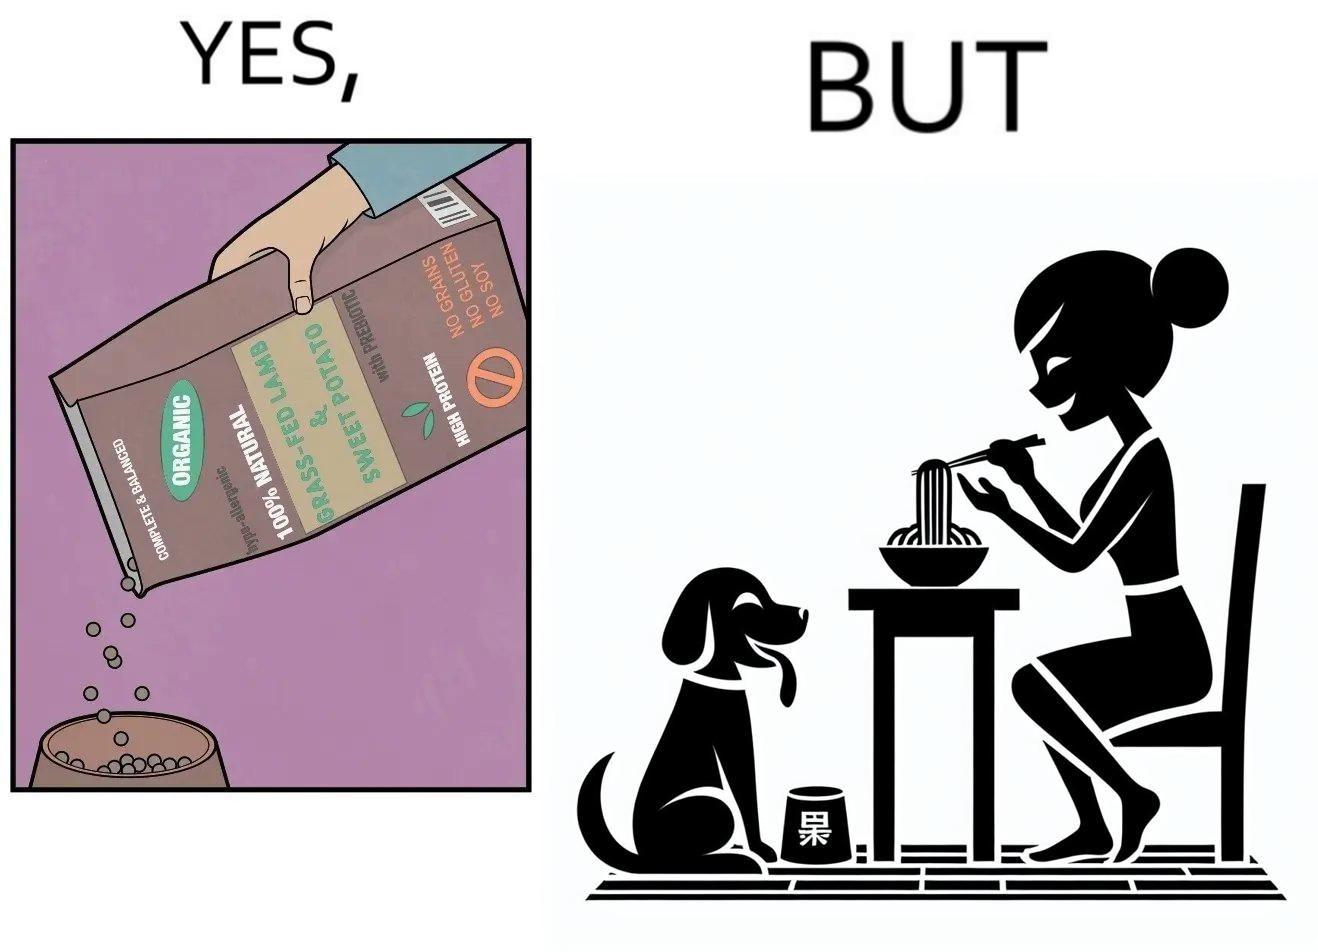What is shown in this image? The image is funny because while the food for the dog that the woman pours is well balanced, the food that she herself is eating is bad for her health. 